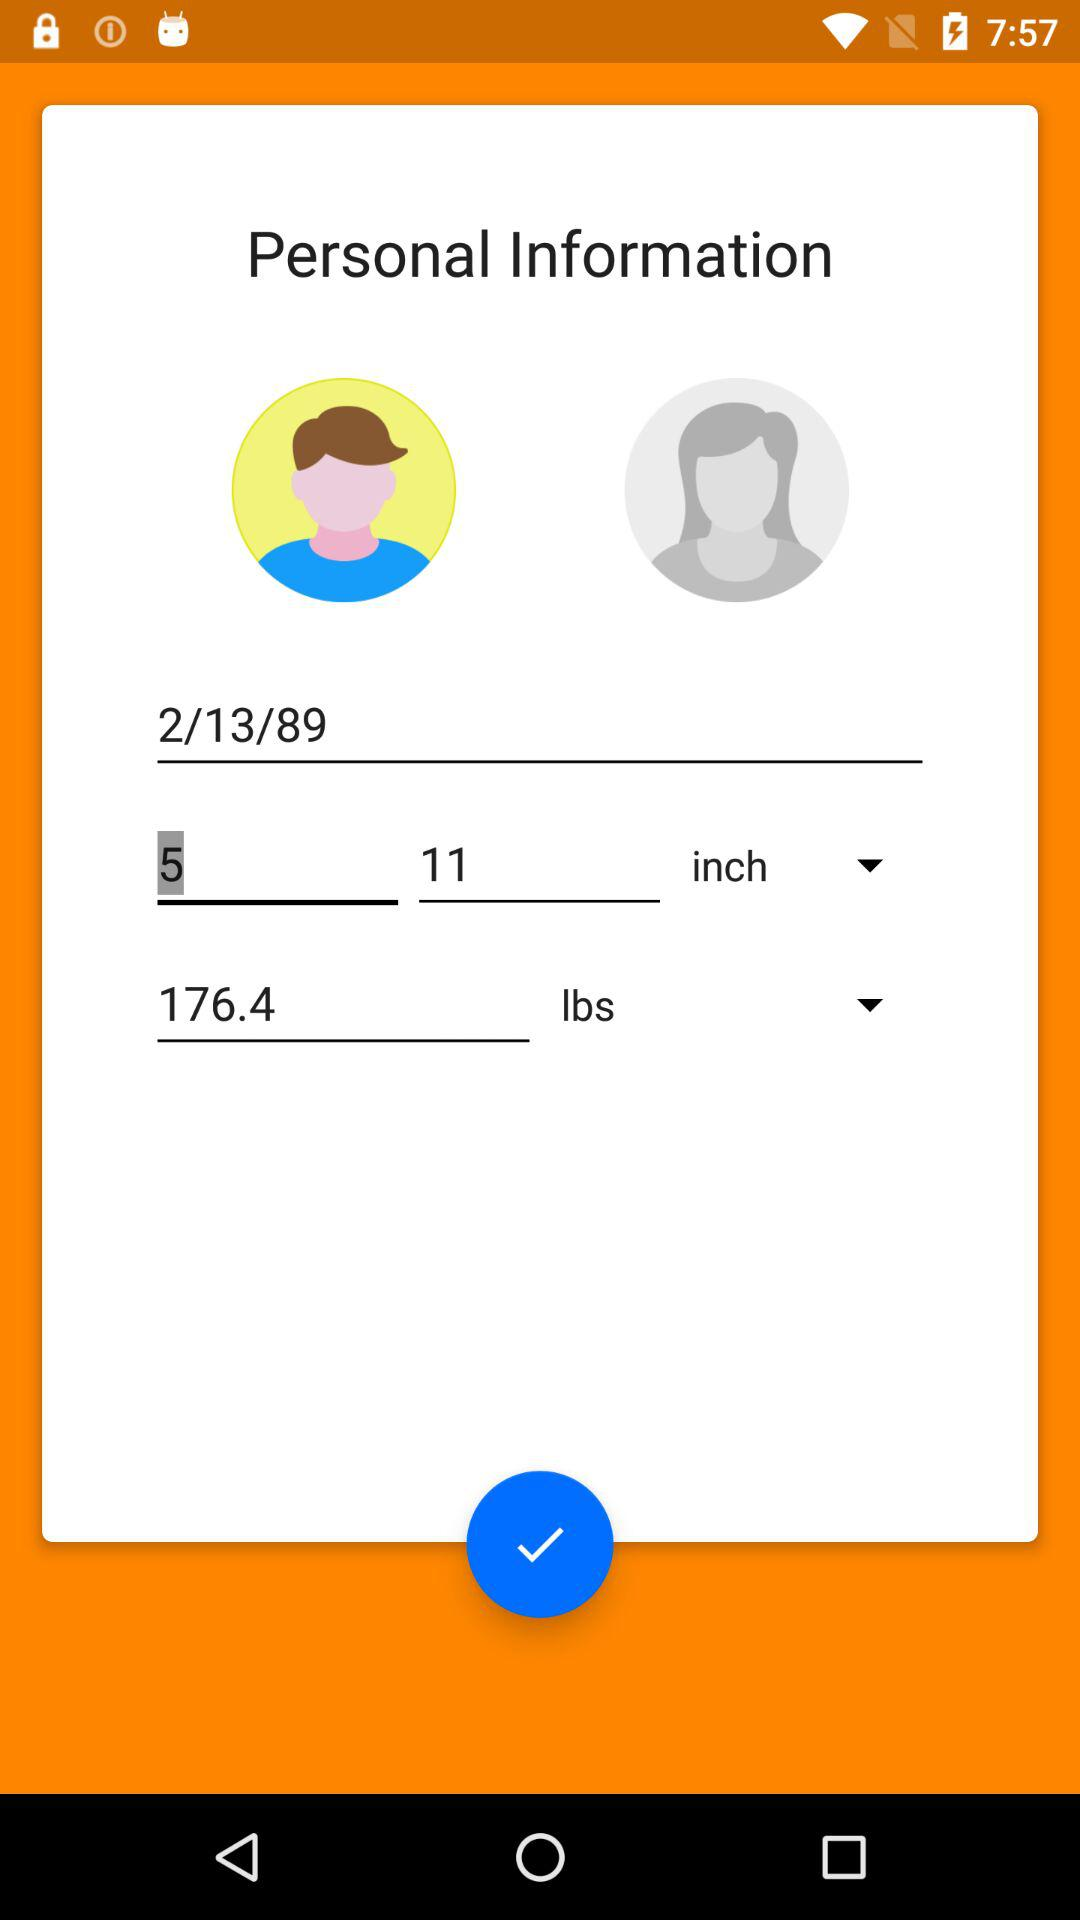Which gender is selected? The selected gender is male. 